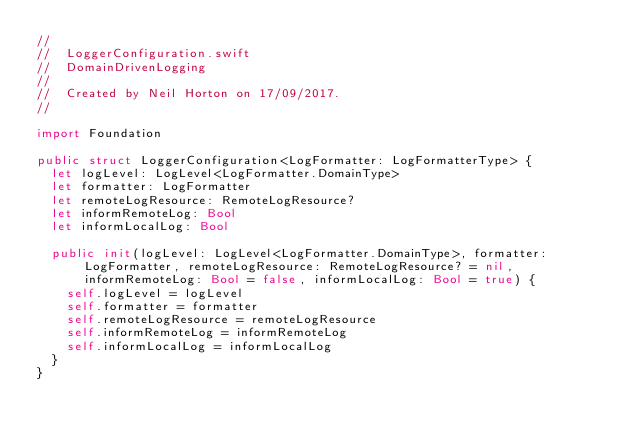Convert code to text. <code><loc_0><loc_0><loc_500><loc_500><_Swift_>//
//  LoggerConfiguration.swift
//  DomainDrivenLogging
//
//  Created by Neil Horton on 17/09/2017.
//

import Foundation

public struct LoggerConfiguration<LogFormatter: LogFormatterType> {
  let logLevel: LogLevel<LogFormatter.DomainType>
  let formatter: LogFormatter
  let remoteLogResource: RemoteLogResource?
  let informRemoteLog: Bool
  let informLocalLog: Bool
  
  public init(logLevel: LogLevel<LogFormatter.DomainType>, formatter: LogFormatter, remoteLogResource: RemoteLogResource? = nil, informRemoteLog: Bool = false, informLocalLog: Bool = true) {
    self.logLevel = logLevel
    self.formatter = formatter
    self.remoteLogResource = remoteLogResource
    self.informRemoteLog = informRemoteLog
    self.informLocalLog = informLocalLog
  }
}
</code> 